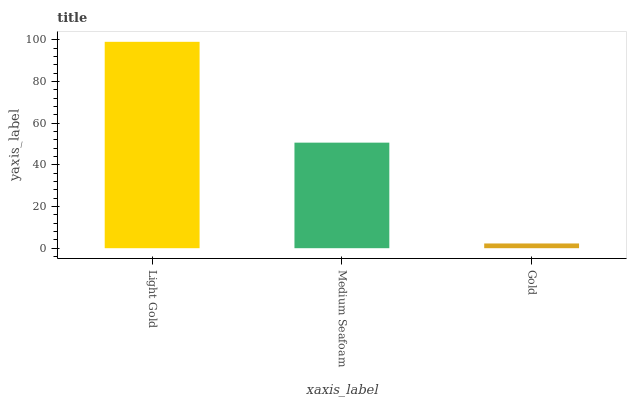Is Gold the minimum?
Answer yes or no. Yes. Is Light Gold the maximum?
Answer yes or no. Yes. Is Medium Seafoam the minimum?
Answer yes or no. No. Is Medium Seafoam the maximum?
Answer yes or no. No. Is Light Gold greater than Medium Seafoam?
Answer yes or no. Yes. Is Medium Seafoam less than Light Gold?
Answer yes or no. Yes. Is Medium Seafoam greater than Light Gold?
Answer yes or no. No. Is Light Gold less than Medium Seafoam?
Answer yes or no. No. Is Medium Seafoam the high median?
Answer yes or no. Yes. Is Medium Seafoam the low median?
Answer yes or no. Yes. Is Light Gold the high median?
Answer yes or no. No. Is Light Gold the low median?
Answer yes or no. No. 